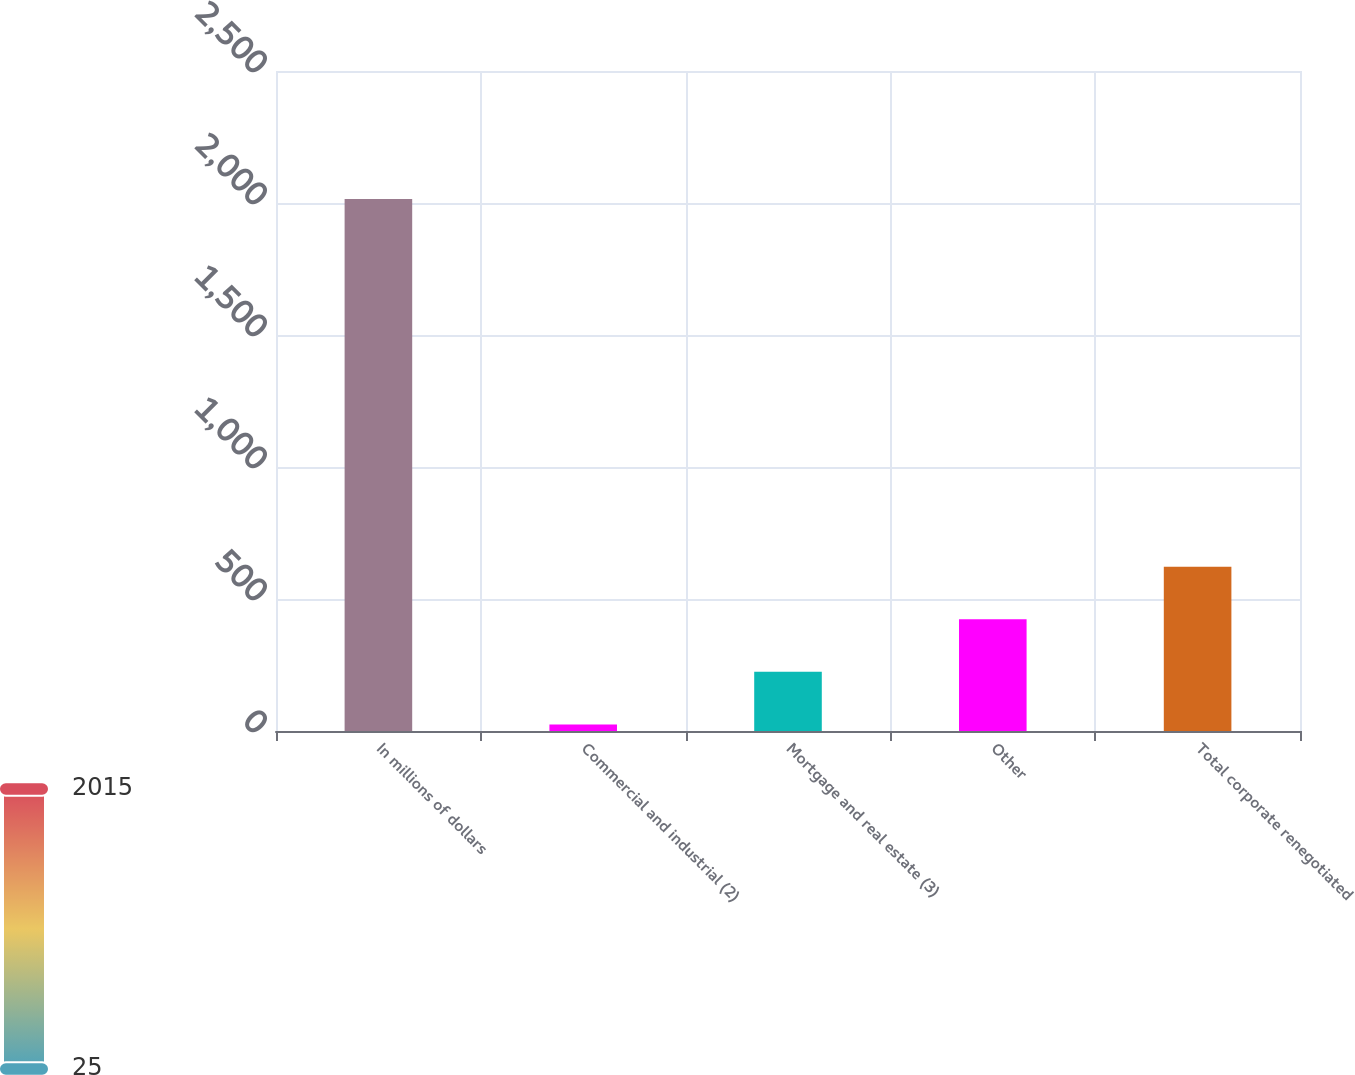Convert chart. <chart><loc_0><loc_0><loc_500><loc_500><bar_chart><fcel>In millions of dollars<fcel>Commercial and industrial (2)<fcel>Mortgage and real estate (3)<fcel>Other<fcel>Total corporate renegotiated<nl><fcel>2015<fcel>25<fcel>224<fcel>423<fcel>622<nl></chart> 